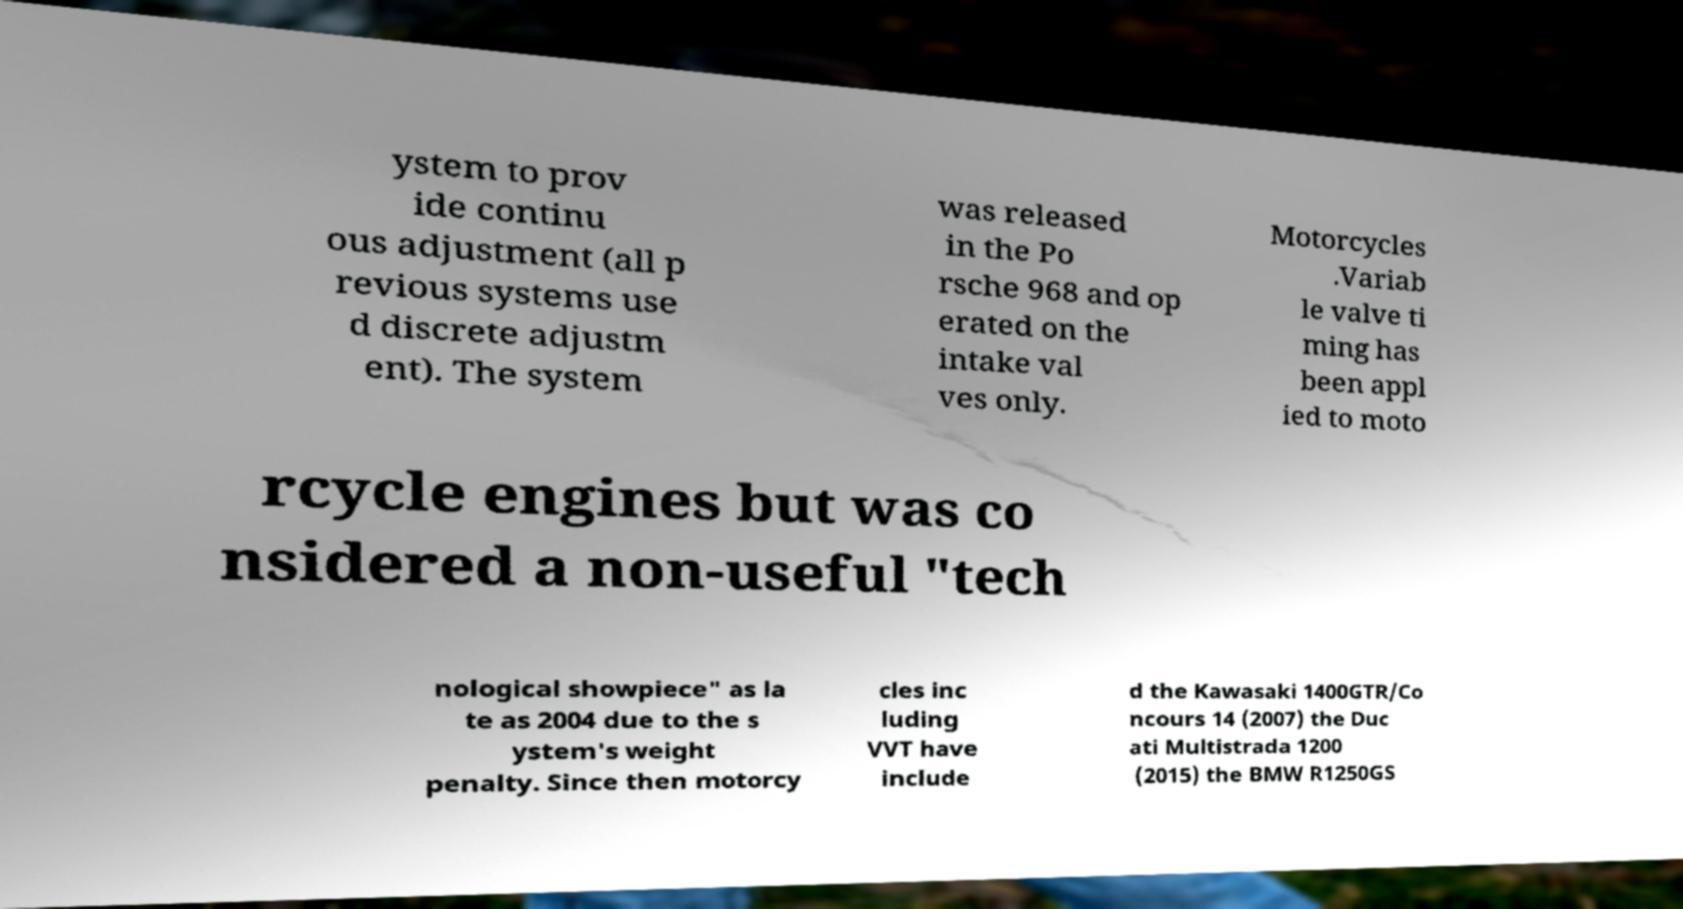Can you read and provide the text displayed in the image?This photo seems to have some interesting text. Can you extract and type it out for me? ystem to prov ide continu ous adjustment (all p revious systems use d discrete adjustm ent). The system was released in the Po rsche 968 and op erated on the intake val ves only. Motorcycles .Variab le valve ti ming has been appl ied to moto rcycle engines but was co nsidered a non-useful "tech nological showpiece" as la te as 2004 due to the s ystem's weight penalty. Since then motorcy cles inc luding VVT have include d the Kawasaki 1400GTR/Co ncours 14 (2007) the Duc ati Multistrada 1200 (2015) the BMW R1250GS 